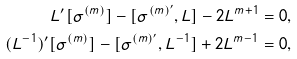<formula> <loc_0><loc_0><loc_500><loc_500>L ^ { \prime } [ \sigma ^ { ( m ) } ] - [ \sigma ^ { ( m ) ^ { \prime } } , L ] - 2 L ^ { m + 1 } & = 0 , \\ ( L ^ { - 1 } ) ^ { \prime } [ \sigma ^ { ( m ) } ] - [ \sigma ^ { ( m ) ^ { \prime } } , L ^ { - 1 } ] + 2 L ^ { m - 1 } & = 0 ,</formula> 